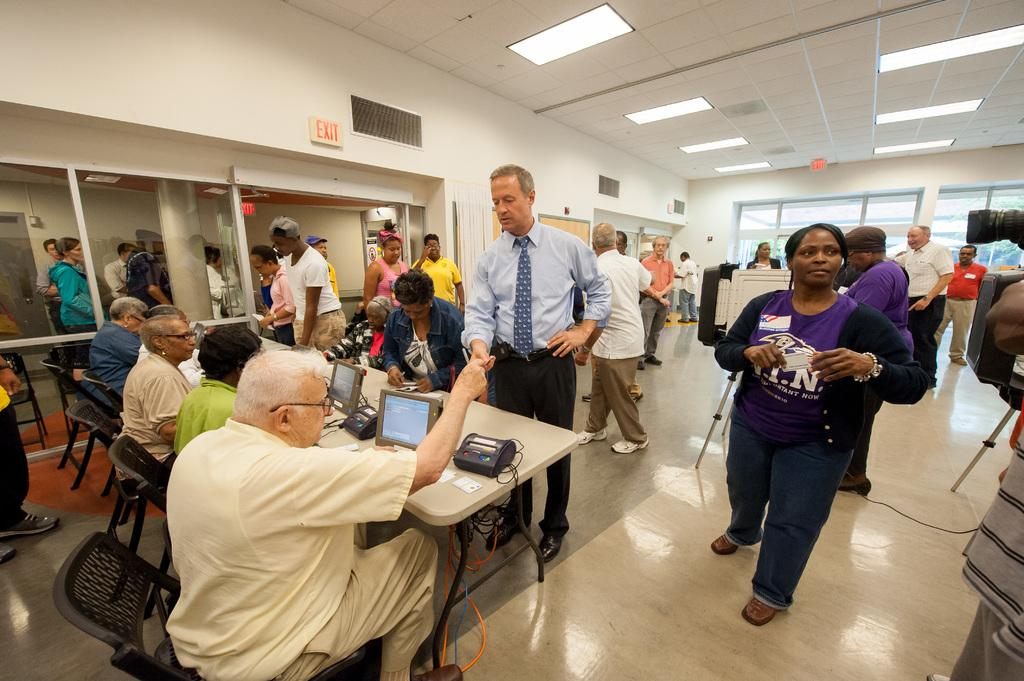<image>
Create a compact narrative representing the image presented. A group of people are in a room some sitting using computers andsome standing and there is an exit sign on the wall. 